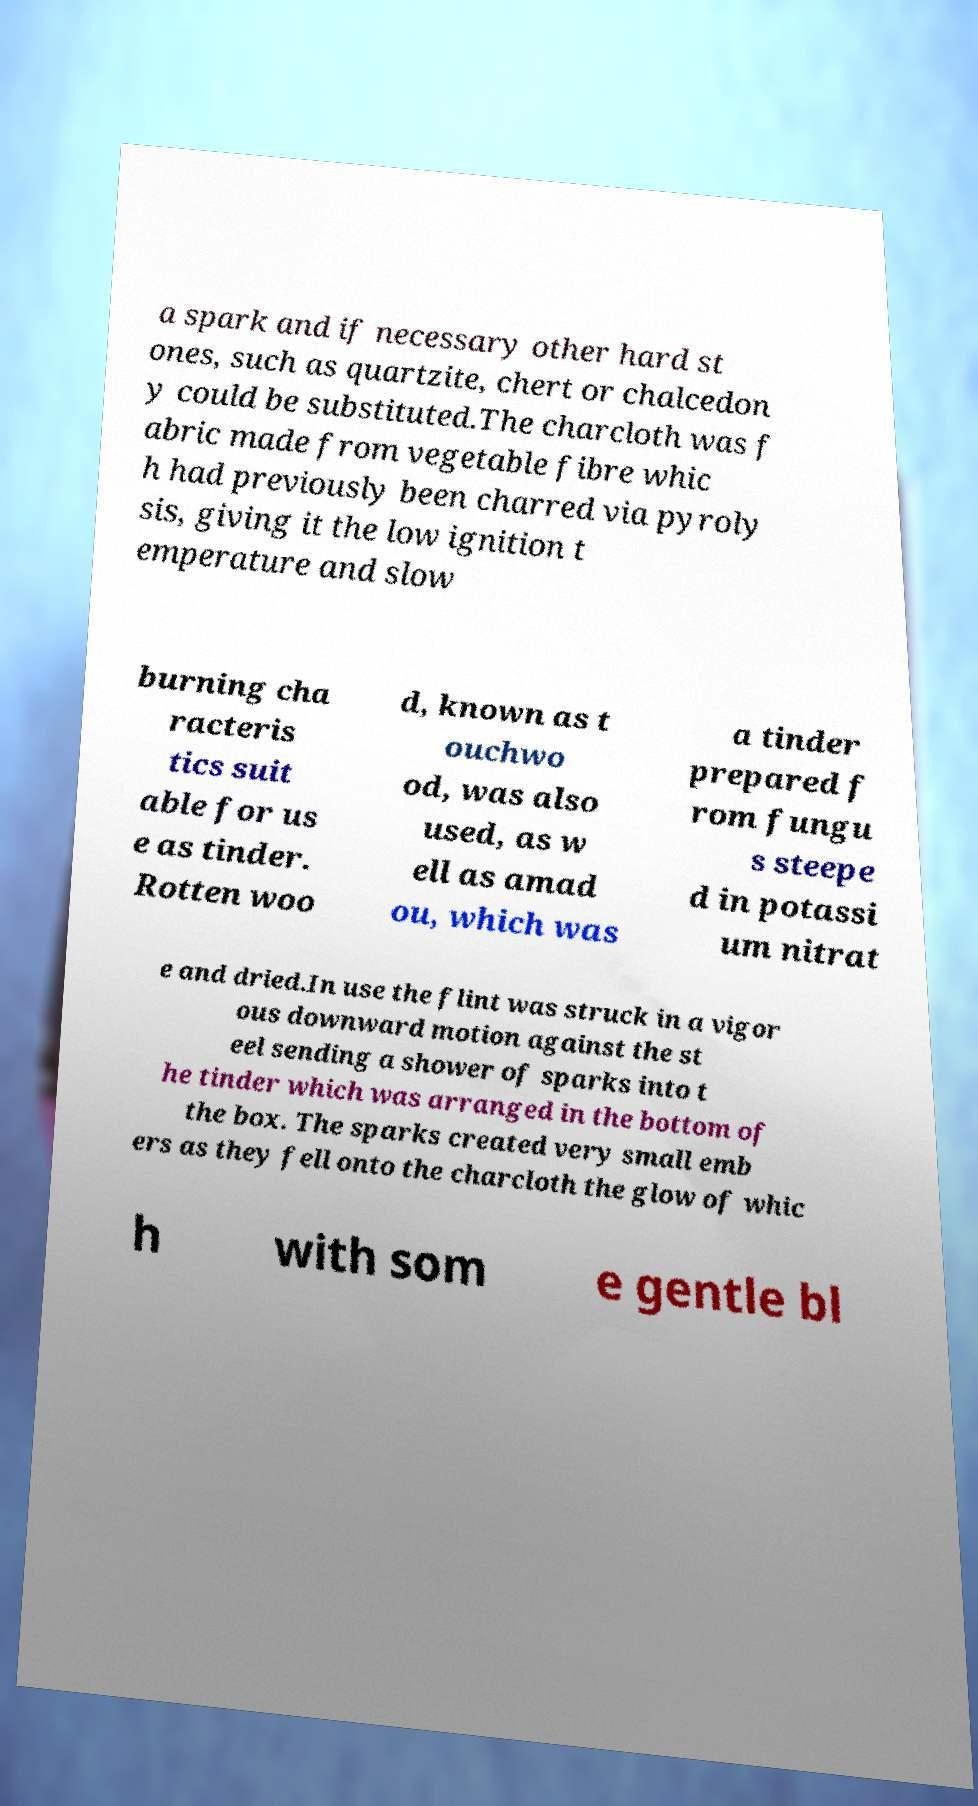For documentation purposes, I need the text within this image transcribed. Could you provide that? a spark and if necessary other hard st ones, such as quartzite, chert or chalcedon y could be substituted.The charcloth was f abric made from vegetable fibre whic h had previously been charred via pyroly sis, giving it the low ignition t emperature and slow burning cha racteris tics suit able for us e as tinder. Rotten woo d, known as t ouchwo od, was also used, as w ell as amad ou, which was a tinder prepared f rom fungu s steepe d in potassi um nitrat e and dried.In use the flint was struck in a vigor ous downward motion against the st eel sending a shower of sparks into t he tinder which was arranged in the bottom of the box. The sparks created very small emb ers as they fell onto the charcloth the glow of whic h with som e gentle bl 